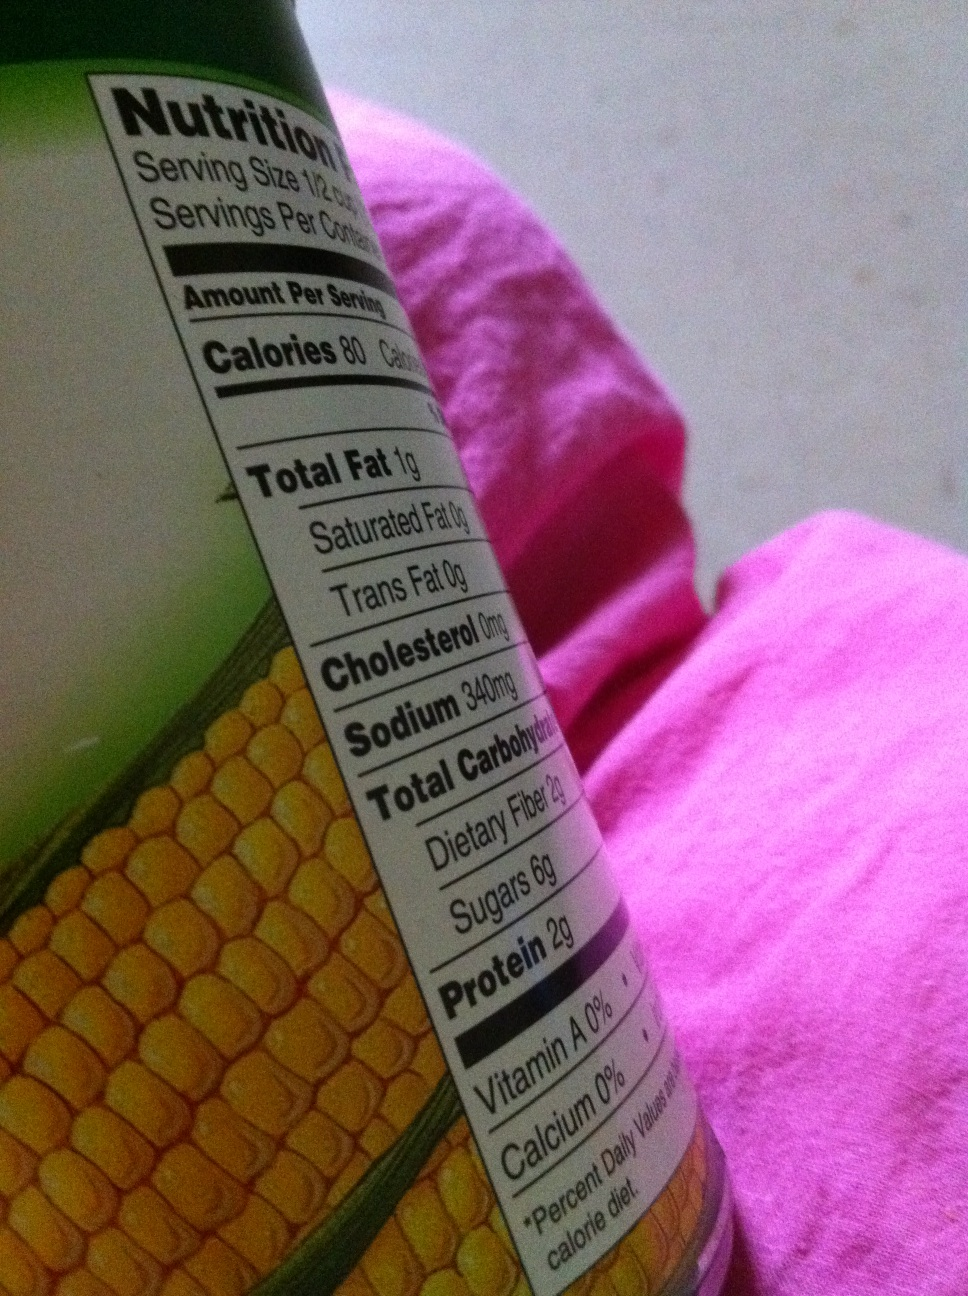How can I incorporate the contents of this can into a healthy meal? Canned corn can be a healthy addition to a variety of dishes. You might mix it into a vegetable salad, add it to a hearty soup, or combine it with black beans and tomatoes for a nutritious salsa. Just remember to drain and rinse the corn to reduce the sodium content. 